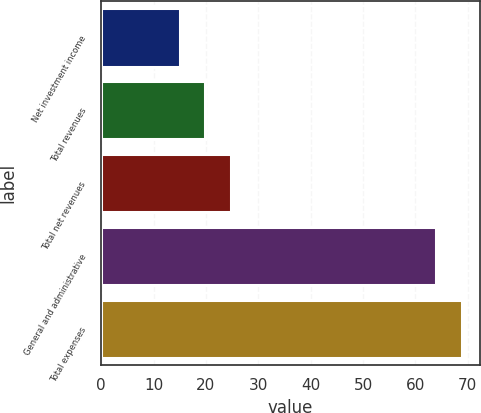Convert chart. <chart><loc_0><loc_0><loc_500><loc_500><bar_chart><fcel>Net investment income<fcel>Total revenues<fcel>Total net revenues<fcel>General and administrative<fcel>Total expenses<nl><fcel>15<fcel>19.9<fcel>24.8<fcel>64<fcel>68.9<nl></chart> 